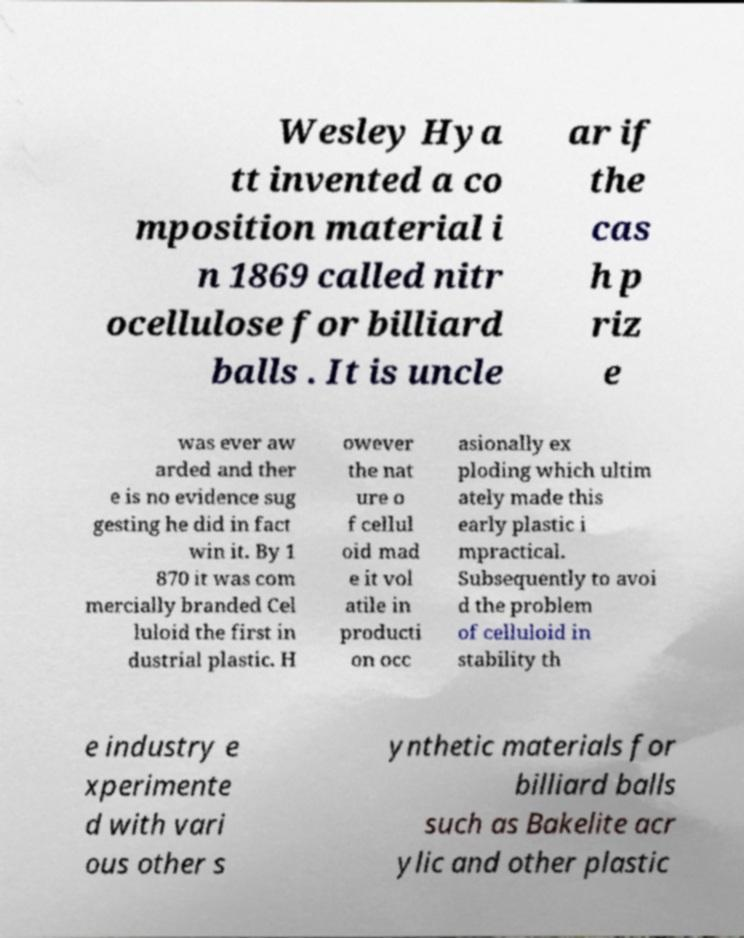For documentation purposes, I need the text within this image transcribed. Could you provide that? Wesley Hya tt invented a co mposition material i n 1869 called nitr ocellulose for billiard balls . It is uncle ar if the cas h p riz e was ever aw arded and ther e is no evidence sug gesting he did in fact win it. By 1 870 it was com mercially branded Cel luloid the first in dustrial plastic. H owever the nat ure o f cellul oid mad e it vol atile in producti on occ asionally ex ploding which ultim ately made this early plastic i mpractical. Subsequently to avoi d the problem of celluloid in stability th e industry e xperimente d with vari ous other s ynthetic materials for billiard balls such as Bakelite acr ylic and other plastic 